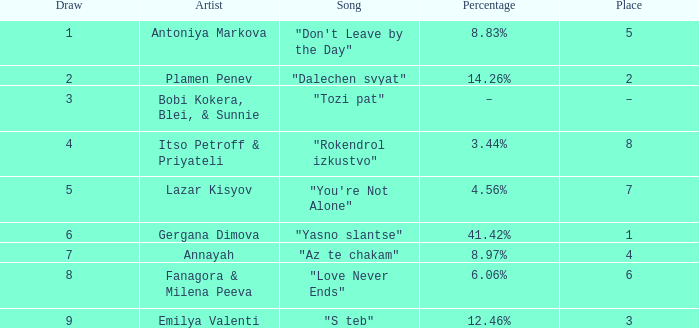Which Percentage has a Draw of 6? 41.42%. I'm looking to parse the entire table for insights. Could you assist me with that? {'header': ['Draw', 'Artist', 'Song', 'Percentage', 'Place'], 'rows': [['1', 'Antoniya Markova', '"Don\'t Leave by the Day"', '8.83%', '5'], ['2', 'Plamen Penev', '"Dalechen svyat"', '14.26%', '2'], ['3', 'Bobi Kokera, Blei, & Sunnie', '"Tozi pat"', '–', '–'], ['4', 'Itso Petroff & Priyateli', '"Rokendrol izkustvo"', '3.44%', '8'], ['5', 'Lazar Kisyov', '"You\'re Not Alone"', '4.56%', '7'], ['6', 'Gergana Dimova', '"Yasno slantse"', '41.42%', '1'], ['7', 'Annayah', '"Az te chakam"', '8.97%', '4'], ['8', 'Fanagora & Milena Peeva', '"Love Never Ends"', '6.06%', '6'], ['9', 'Emilya Valenti', '"S teb"', '12.46%', '3']]} 